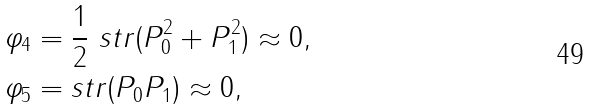Convert formula to latex. <formula><loc_0><loc_0><loc_500><loc_500>\varphi _ { 4 } & = \frac { 1 } { 2 } \ s t r ( P _ { 0 } ^ { 2 } + P _ { 1 } ^ { 2 } ) \approx 0 , \\ \varphi _ { 5 } & = s t r ( P _ { 0 } P _ { 1 } ) \approx 0 ,</formula> 